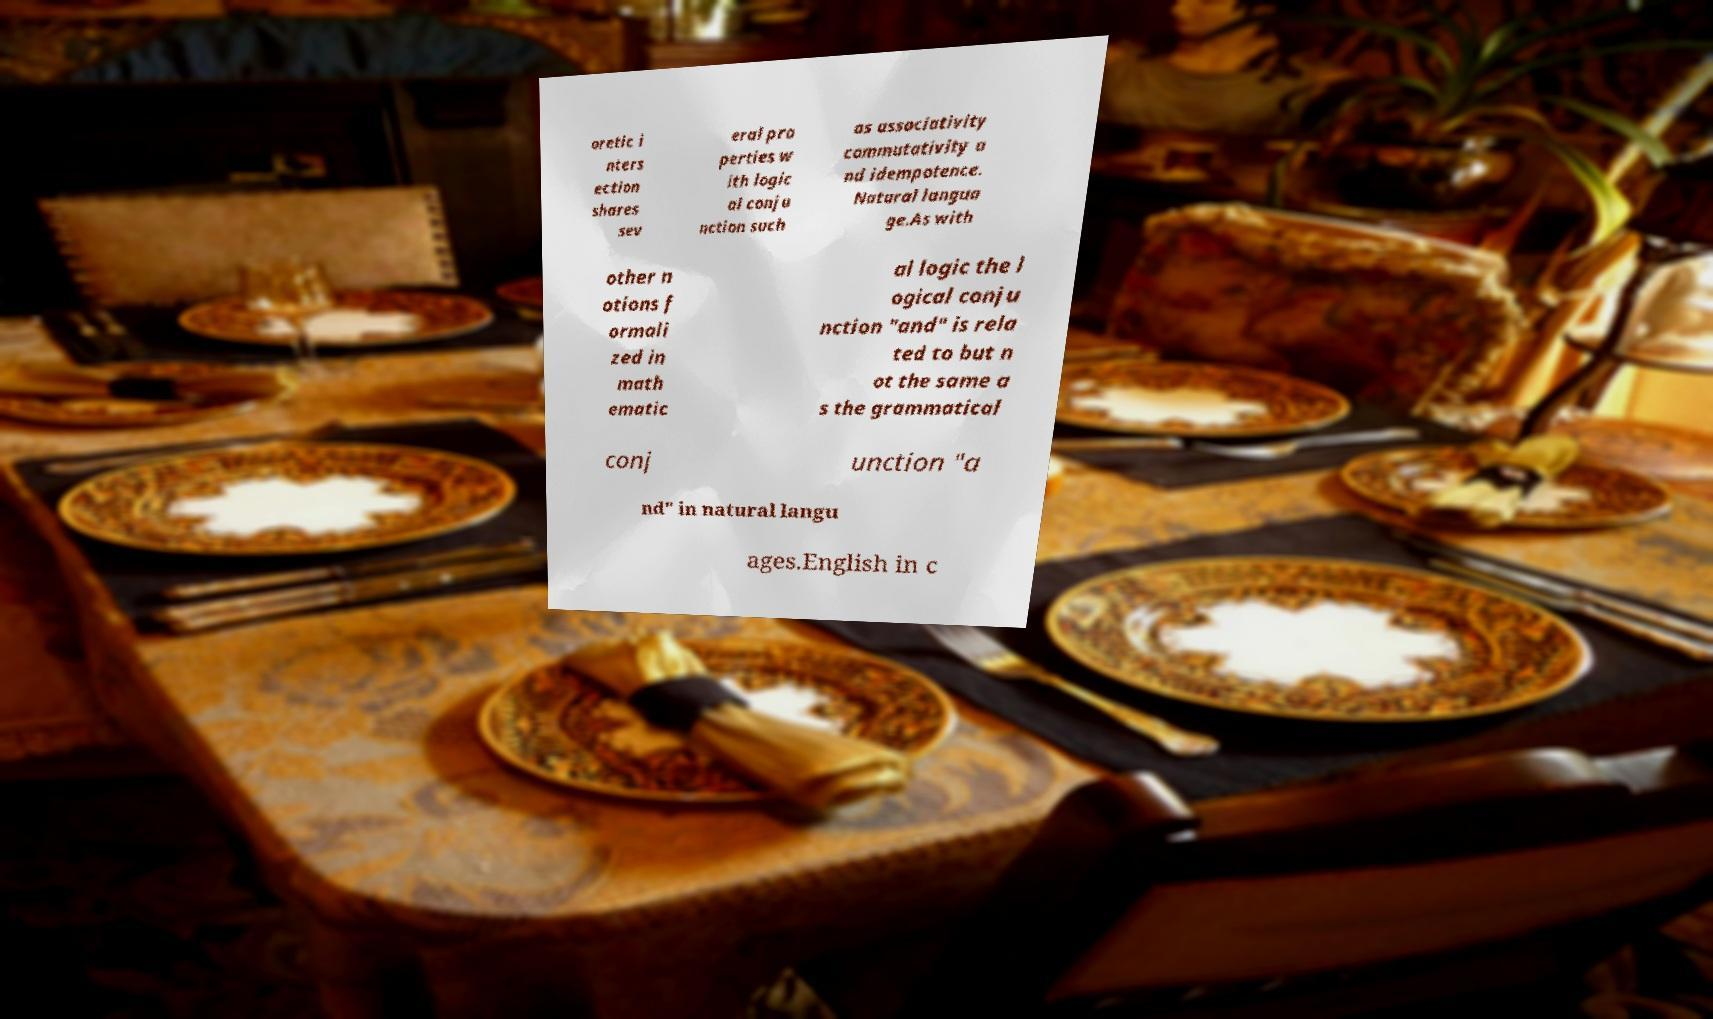Please read and relay the text visible in this image. What does it say? oretic i nters ection shares sev eral pro perties w ith logic al conju nction such as associativity commutativity a nd idempotence. Natural langua ge.As with other n otions f ormali zed in math ematic al logic the l ogical conju nction "and" is rela ted to but n ot the same a s the grammatical conj unction "a nd" in natural langu ages.English in c 